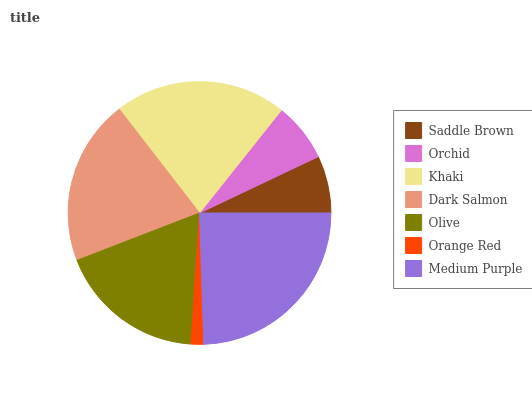Is Orange Red the minimum?
Answer yes or no. Yes. Is Medium Purple the maximum?
Answer yes or no. Yes. Is Orchid the minimum?
Answer yes or no. No. Is Orchid the maximum?
Answer yes or no. No. Is Orchid greater than Saddle Brown?
Answer yes or no. Yes. Is Saddle Brown less than Orchid?
Answer yes or no. Yes. Is Saddle Brown greater than Orchid?
Answer yes or no. No. Is Orchid less than Saddle Brown?
Answer yes or no. No. Is Olive the high median?
Answer yes or no. Yes. Is Olive the low median?
Answer yes or no. Yes. Is Orange Red the high median?
Answer yes or no. No. Is Orchid the low median?
Answer yes or no. No. 